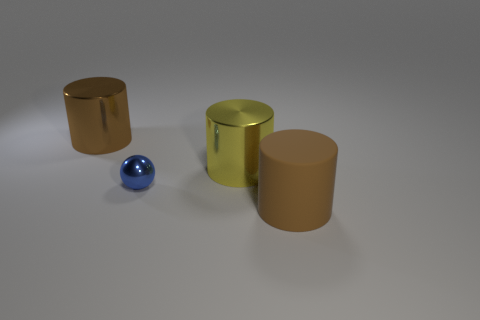What time of day does the lighting in this scene suggest? The lighting in the scene doesn't strongly indicate a specific time of day. It appears to be neutral, artificial lighting, likely from an indoor environment, which does not change with the time of day. 